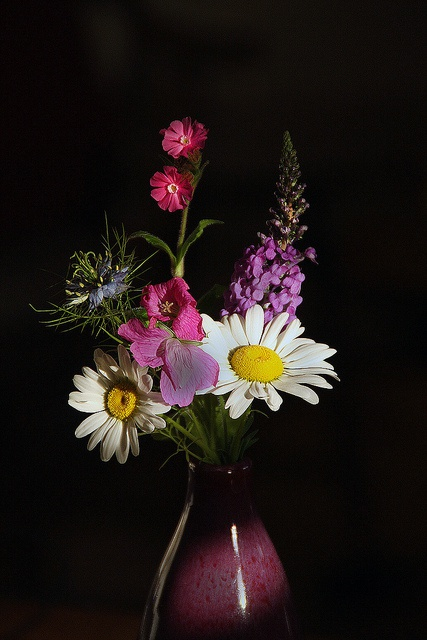Describe the objects in this image and their specific colors. I can see potted plant in black, maroon, lightgray, and darkgreen tones and vase in black, maroon, purple, and brown tones in this image. 